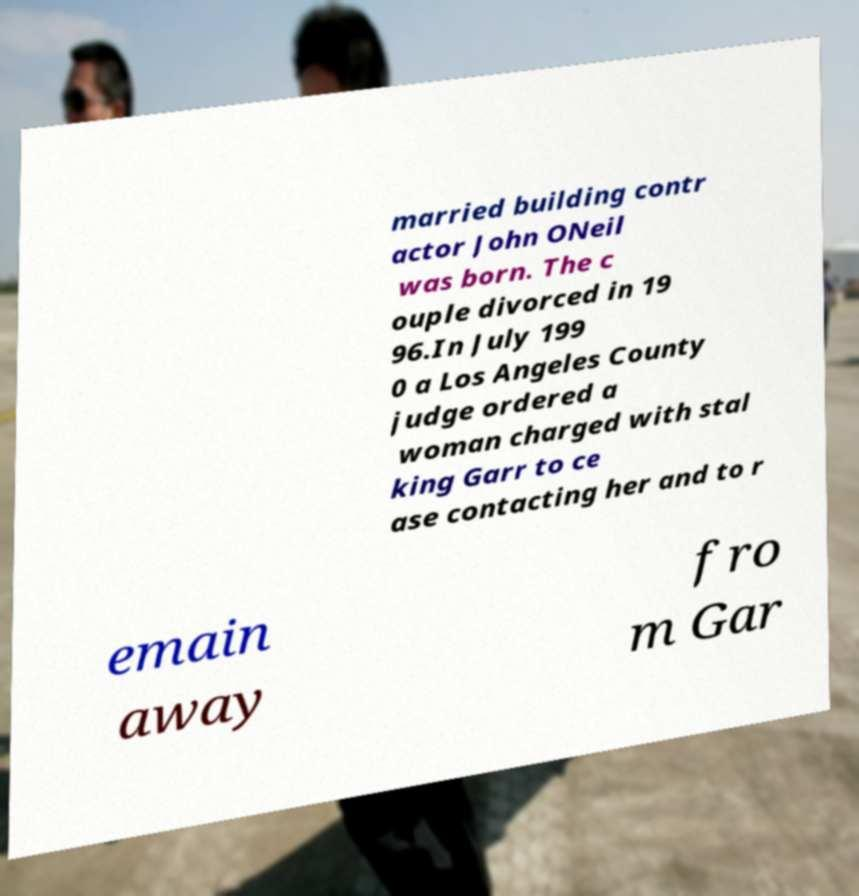Could you assist in decoding the text presented in this image and type it out clearly? married building contr actor John ONeil was born. The c ouple divorced in 19 96.In July 199 0 a Los Angeles County judge ordered a woman charged with stal king Garr to ce ase contacting her and to r emain away fro m Gar 